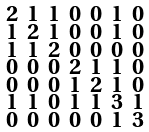<formula> <loc_0><loc_0><loc_500><loc_500>\begin{smallmatrix} 2 & 1 & 1 & 0 & 0 & 1 & 0 \\ 1 & 2 & 1 & 0 & 0 & 1 & 0 \\ 1 & 1 & 2 & 0 & 0 & 0 & 0 \\ 0 & 0 & 0 & 2 & 1 & 1 & 0 \\ 0 & 0 & 0 & 1 & 2 & 1 & 0 \\ 1 & 1 & 0 & 1 & 1 & 3 & 1 \\ 0 & 0 & 0 & 0 & 0 & 1 & 3 \end{smallmatrix}</formula> 